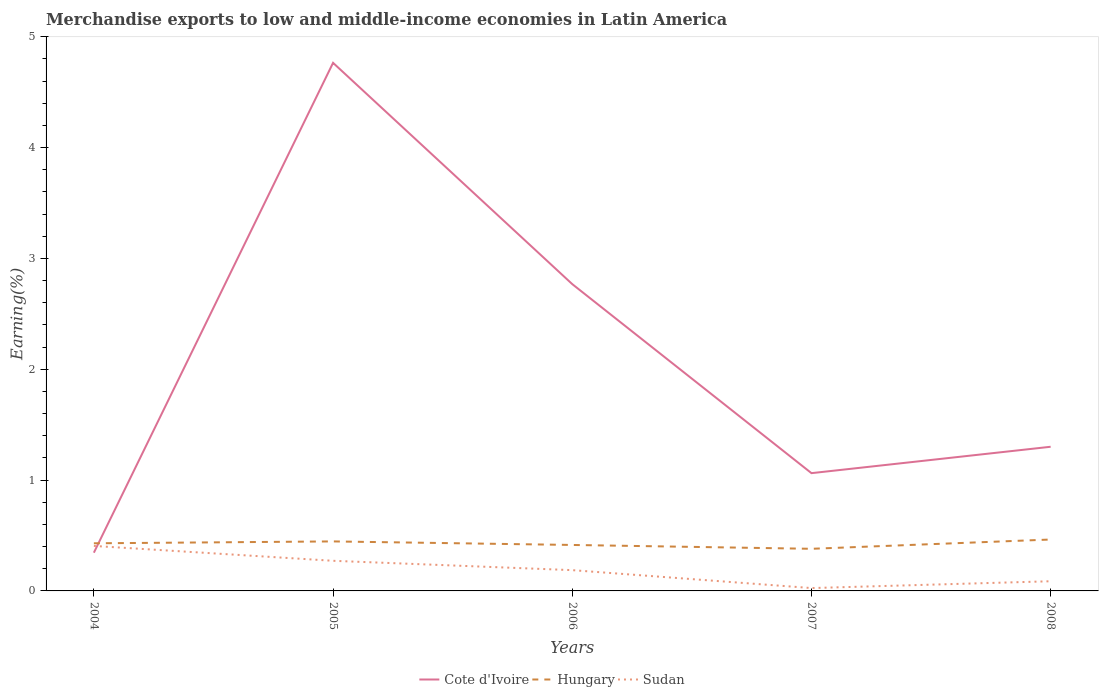How many different coloured lines are there?
Provide a short and direct response. 3. Is the number of lines equal to the number of legend labels?
Give a very brief answer. Yes. Across all years, what is the maximum percentage of amount earned from merchandise exports in Hungary?
Your response must be concise. 0.38. What is the total percentage of amount earned from merchandise exports in Cote d'Ivoire in the graph?
Keep it short and to the point. -2.42. What is the difference between the highest and the second highest percentage of amount earned from merchandise exports in Cote d'Ivoire?
Provide a succinct answer. 4.42. Is the percentage of amount earned from merchandise exports in Cote d'Ivoire strictly greater than the percentage of amount earned from merchandise exports in Sudan over the years?
Your answer should be compact. No. How many lines are there?
Offer a very short reply. 3. How many years are there in the graph?
Offer a very short reply. 5. What is the difference between two consecutive major ticks on the Y-axis?
Your answer should be very brief. 1. Does the graph contain any zero values?
Keep it short and to the point. No. Where does the legend appear in the graph?
Give a very brief answer. Bottom center. How are the legend labels stacked?
Make the answer very short. Horizontal. What is the title of the graph?
Provide a short and direct response. Merchandise exports to low and middle-income economies in Latin America. What is the label or title of the Y-axis?
Provide a succinct answer. Earning(%). What is the Earning(%) of Cote d'Ivoire in 2004?
Your response must be concise. 0.34. What is the Earning(%) of Hungary in 2004?
Your response must be concise. 0.43. What is the Earning(%) in Sudan in 2004?
Your response must be concise. 0.41. What is the Earning(%) of Cote d'Ivoire in 2005?
Keep it short and to the point. 4.76. What is the Earning(%) of Hungary in 2005?
Ensure brevity in your answer.  0.45. What is the Earning(%) in Sudan in 2005?
Offer a terse response. 0.27. What is the Earning(%) of Cote d'Ivoire in 2006?
Your answer should be compact. 2.77. What is the Earning(%) in Hungary in 2006?
Make the answer very short. 0.41. What is the Earning(%) in Sudan in 2006?
Offer a very short reply. 0.19. What is the Earning(%) of Cote d'Ivoire in 2007?
Your response must be concise. 1.06. What is the Earning(%) in Hungary in 2007?
Give a very brief answer. 0.38. What is the Earning(%) in Sudan in 2007?
Your response must be concise. 0.03. What is the Earning(%) of Cote d'Ivoire in 2008?
Give a very brief answer. 1.3. What is the Earning(%) of Hungary in 2008?
Make the answer very short. 0.46. What is the Earning(%) in Sudan in 2008?
Your answer should be compact. 0.09. Across all years, what is the maximum Earning(%) of Cote d'Ivoire?
Give a very brief answer. 4.76. Across all years, what is the maximum Earning(%) of Hungary?
Your answer should be very brief. 0.46. Across all years, what is the maximum Earning(%) in Sudan?
Provide a succinct answer. 0.41. Across all years, what is the minimum Earning(%) of Cote d'Ivoire?
Your answer should be compact. 0.34. Across all years, what is the minimum Earning(%) in Hungary?
Your answer should be very brief. 0.38. Across all years, what is the minimum Earning(%) in Sudan?
Your response must be concise. 0.03. What is the total Earning(%) in Cote d'Ivoire in the graph?
Provide a short and direct response. 10.24. What is the total Earning(%) of Hungary in the graph?
Provide a succinct answer. 2.13. What is the total Earning(%) of Sudan in the graph?
Ensure brevity in your answer.  0.98. What is the difference between the Earning(%) in Cote d'Ivoire in 2004 and that in 2005?
Offer a terse response. -4.42. What is the difference between the Earning(%) of Hungary in 2004 and that in 2005?
Make the answer very short. -0.02. What is the difference between the Earning(%) in Sudan in 2004 and that in 2005?
Provide a short and direct response. 0.13. What is the difference between the Earning(%) of Cote d'Ivoire in 2004 and that in 2006?
Make the answer very short. -2.42. What is the difference between the Earning(%) in Hungary in 2004 and that in 2006?
Ensure brevity in your answer.  0.01. What is the difference between the Earning(%) in Sudan in 2004 and that in 2006?
Make the answer very short. 0.22. What is the difference between the Earning(%) of Cote d'Ivoire in 2004 and that in 2007?
Your answer should be compact. -0.72. What is the difference between the Earning(%) of Hungary in 2004 and that in 2007?
Make the answer very short. 0.05. What is the difference between the Earning(%) in Sudan in 2004 and that in 2007?
Ensure brevity in your answer.  0.38. What is the difference between the Earning(%) in Cote d'Ivoire in 2004 and that in 2008?
Provide a short and direct response. -0.96. What is the difference between the Earning(%) of Hungary in 2004 and that in 2008?
Offer a terse response. -0.03. What is the difference between the Earning(%) in Sudan in 2004 and that in 2008?
Your answer should be compact. 0.32. What is the difference between the Earning(%) of Cote d'Ivoire in 2005 and that in 2006?
Your answer should be very brief. 2. What is the difference between the Earning(%) in Hungary in 2005 and that in 2006?
Your answer should be very brief. 0.03. What is the difference between the Earning(%) in Sudan in 2005 and that in 2006?
Your response must be concise. 0.08. What is the difference between the Earning(%) in Cote d'Ivoire in 2005 and that in 2007?
Your response must be concise. 3.7. What is the difference between the Earning(%) in Hungary in 2005 and that in 2007?
Your answer should be compact. 0.07. What is the difference between the Earning(%) of Sudan in 2005 and that in 2007?
Ensure brevity in your answer.  0.25. What is the difference between the Earning(%) in Cote d'Ivoire in 2005 and that in 2008?
Your answer should be compact. 3.46. What is the difference between the Earning(%) of Hungary in 2005 and that in 2008?
Your response must be concise. -0.02. What is the difference between the Earning(%) of Sudan in 2005 and that in 2008?
Make the answer very short. 0.18. What is the difference between the Earning(%) in Cote d'Ivoire in 2006 and that in 2007?
Provide a short and direct response. 1.71. What is the difference between the Earning(%) of Hungary in 2006 and that in 2007?
Give a very brief answer. 0.03. What is the difference between the Earning(%) of Sudan in 2006 and that in 2007?
Your answer should be compact. 0.16. What is the difference between the Earning(%) of Cote d'Ivoire in 2006 and that in 2008?
Keep it short and to the point. 1.47. What is the difference between the Earning(%) in Hungary in 2006 and that in 2008?
Ensure brevity in your answer.  -0.05. What is the difference between the Earning(%) of Sudan in 2006 and that in 2008?
Give a very brief answer. 0.1. What is the difference between the Earning(%) of Cote d'Ivoire in 2007 and that in 2008?
Provide a short and direct response. -0.24. What is the difference between the Earning(%) of Hungary in 2007 and that in 2008?
Your response must be concise. -0.08. What is the difference between the Earning(%) of Sudan in 2007 and that in 2008?
Give a very brief answer. -0.06. What is the difference between the Earning(%) in Cote d'Ivoire in 2004 and the Earning(%) in Hungary in 2005?
Keep it short and to the point. -0.1. What is the difference between the Earning(%) in Cote d'Ivoire in 2004 and the Earning(%) in Sudan in 2005?
Provide a succinct answer. 0.07. What is the difference between the Earning(%) in Hungary in 2004 and the Earning(%) in Sudan in 2005?
Ensure brevity in your answer.  0.16. What is the difference between the Earning(%) of Cote d'Ivoire in 2004 and the Earning(%) of Hungary in 2006?
Give a very brief answer. -0.07. What is the difference between the Earning(%) in Cote d'Ivoire in 2004 and the Earning(%) in Sudan in 2006?
Your answer should be very brief. 0.16. What is the difference between the Earning(%) of Hungary in 2004 and the Earning(%) of Sudan in 2006?
Ensure brevity in your answer.  0.24. What is the difference between the Earning(%) in Cote d'Ivoire in 2004 and the Earning(%) in Hungary in 2007?
Your answer should be compact. -0.04. What is the difference between the Earning(%) in Cote d'Ivoire in 2004 and the Earning(%) in Sudan in 2007?
Ensure brevity in your answer.  0.32. What is the difference between the Earning(%) in Hungary in 2004 and the Earning(%) in Sudan in 2007?
Offer a very short reply. 0.4. What is the difference between the Earning(%) in Cote d'Ivoire in 2004 and the Earning(%) in Hungary in 2008?
Keep it short and to the point. -0.12. What is the difference between the Earning(%) in Cote d'Ivoire in 2004 and the Earning(%) in Sudan in 2008?
Provide a short and direct response. 0.26. What is the difference between the Earning(%) in Hungary in 2004 and the Earning(%) in Sudan in 2008?
Ensure brevity in your answer.  0.34. What is the difference between the Earning(%) in Cote d'Ivoire in 2005 and the Earning(%) in Hungary in 2006?
Keep it short and to the point. 4.35. What is the difference between the Earning(%) of Cote d'Ivoire in 2005 and the Earning(%) of Sudan in 2006?
Keep it short and to the point. 4.58. What is the difference between the Earning(%) of Hungary in 2005 and the Earning(%) of Sudan in 2006?
Your answer should be very brief. 0.26. What is the difference between the Earning(%) in Cote d'Ivoire in 2005 and the Earning(%) in Hungary in 2007?
Give a very brief answer. 4.38. What is the difference between the Earning(%) of Cote d'Ivoire in 2005 and the Earning(%) of Sudan in 2007?
Provide a succinct answer. 4.74. What is the difference between the Earning(%) of Hungary in 2005 and the Earning(%) of Sudan in 2007?
Offer a terse response. 0.42. What is the difference between the Earning(%) in Cote d'Ivoire in 2005 and the Earning(%) in Hungary in 2008?
Offer a terse response. 4.3. What is the difference between the Earning(%) of Cote d'Ivoire in 2005 and the Earning(%) of Sudan in 2008?
Offer a very short reply. 4.68. What is the difference between the Earning(%) in Hungary in 2005 and the Earning(%) in Sudan in 2008?
Make the answer very short. 0.36. What is the difference between the Earning(%) of Cote d'Ivoire in 2006 and the Earning(%) of Hungary in 2007?
Make the answer very short. 2.39. What is the difference between the Earning(%) in Cote d'Ivoire in 2006 and the Earning(%) in Sudan in 2007?
Offer a very short reply. 2.74. What is the difference between the Earning(%) of Hungary in 2006 and the Earning(%) of Sudan in 2007?
Ensure brevity in your answer.  0.39. What is the difference between the Earning(%) of Cote d'Ivoire in 2006 and the Earning(%) of Hungary in 2008?
Give a very brief answer. 2.3. What is the difference between the Earning(%) of Cote d'Ivoire in 2006 and the Earning(%) of Sudan in 2008?
Your answer should be compact. 2.68. What is the difference between the Earning(%) of Hungary in 2006 and the Earning(%) of Sudan in 2008?
Offer a very short reply. 0.33. What is the difference between the Earning(%) in Cote d'Ivoire in 2007 and the Earning(%) in Hungary in 2008?
Your answer should be very brief. 0.6. What is the difference between the Earning(%) of Cote d'Ivoire in 2007 and the Earning(%) of Sudan in 2008?
Your answer should be compact. 0.98. What is the difference between the Earning(%) of Hungary in 2007 and the Earning(%) of Sudan in 2008?
Provide a succinct answer. 0.29. What is the average Earning(%) in Cote d'Ivoire per year?
Offer a very short reply. 2.05. What is the average Earning(%) of Hungary per year?
Offer a terse response. 0.43. What is the average Earning(%) in Sudan per year?
Your response must be concise. 0.2. In the year 2004, what is the difference between the Earning(%) of Cote d'Ivoire and Earning(%) of Hungary?
Your answer should be compact. -0.08. In the year 2004, what is the difference between the Earning(%) of Cote d'Ivoire and Earning(%) of Sudan?
Ensure brevity in your answer.  -0.06. In the year 2004, what is the difference between the Earning(%) in Hungary and Earning(%) in Sudan?
Ensure brevity in your answer.  0.02. In the year 2005, what is the difference between the Earning(%) of Cote d'Ivoire and Earning(%) of Hungary?
Make the answer very short. 4.32. In the year 2005, what is the difference between the Earning(%) in Cote d'Ivoire and Earning(%) in Sudan?
Keep it short and to the point. 4.49. In the year 2005, what is the difference between the Earning(%) of Hungary and Earning(%) of Sudan?
Offer a very short reply. 0.17. In the year 2006, what is the difference between the Earning(%) of Cote d'Ivoire and Earning(%) of Hungary?
Your response must be concise. 2.35. In the year 2006, what is the difference between the Earning(%) in Cote d'Ivoire and Earning(%) in Sudan?
Offer a very short reply. 2.58. In the year 2006, what is the difference between the Earning(%) in Hungary and Earning(%) in Sudan?
Keep it short and to the point. 0.23. In the year 2007, what is the difference between the Earning(%) in Cote d'Ivoire and Earning(%) in Hungary?
Your response must be concise. 0.68. In the year 2007, what is the difference between the Earning(%) of Cote d'Ivoire and Earning(%) of Sudan?
Keep it short and to the point. 1.04. In the year 2007, what is the difference between the Earning(%) in Hungary and Earning(%) in Sudan?
Offer a very short reply. 0.35. In the year 2008, what is the difference between the Earning(%) in Cote d'Ivoire and Earning(%) in Hungary?
Make the answer very short. 0.84. In the year 2008, what is the difference between the Earning(%) in Cote d'Ivoire and Earning(%) in Sudan?
Provide a short and direct response. 1.21. In the year 2008, what is the difference between the Earning(%) in Hungary and Earning(%) in Sudan?
Provide a short and direct response. 0.38. What is the ratio of the Earning(%) in Cote d'Ivoire in 2004 to that in 2005?
Keep it short and to the point. 0.07. What is the ratio of the Earning(%) in Hungary in 2004 to that in 2005?
Offer a very short reply. 0.96. What is the ratio of the Earning(%) of Sudan in 2004 to that in 2005?
Your answer should be very brief. 1.49. What is the ratio of the Earning(%) in Cote d'Ivoire in 2004 to that in 2006?
Offer a terse response. 0.12. What is the ratio of the Earning(%) of Hungary in 2004 to that in 2006?
Your answer should be very brief. 1.04. What is the ratio of the Earning(%) of Sudan in 2004 to that in 2006?
Ensure brevity in your answer.  2.17. What is the ratio of the Earning(%) of Cote d'Ivoire in 2004 to that in 2007?
Provide a succinct answer. 0.32. What is the ratio of the Earning(%) in Hungary in 2004 to that in 2007?
Your answer should be very brief. 1.13. What is the ratio of the Earning(%) of Sudan in 2004 to that in 2007?
Offer a very short reply. 15.79. What is the ratio of the Earning(%) of Cote d'Ivoire in 2004 to that in 2008?
Give a very brief answer. 0.27. What is the ratio of the Earning(%) in Hungary in 2004 to that in 2008?
Your answer should be compact. 0.93. What is the ratio of the Earning(%) of Sudan in 2004 to that in 2008?
Keep it short and to the point. 4.65. What is the ratio of the Earning(%) in Cote d'Ivoire in 2005 to that in 2006?
Ensure brevity in your answer.  1.72. What is the ratio of the Earning(%) in Hungary in 2005 to that in 2006?
Your response must be concise. 1.08. What is the ratio of the Earning(%) in Sudan in 2005 to that in 2006?
Ensure brevity in your answer.  1.45. What is the ratio of the Earning(%) of Cote d'Ivoire in 2005 to that in 2007?
Offer a terse response. 4.48. What is the ratio of the Earning(%) of Hungary in 2005 to that in 2007?
Provide a succinct answer. 1.18. What is the ratio of the Earning(%) of Sudan in 2005 to that in 2007?
Provide a short and direct response. 10.57. What is the ratio of the Earning(%) of Cote d'Ivoire in 2005 to that in 2008?
Give a very brief answer. 3.66. What is the ratio of the Earning(%) in Hungary in 2005 to that in 2008?
Provide a succinct answer. 0.96. What is the ratio of the Earning(%) of Sudan in 2005 to that in 2008?
Offer a terse response. 3.11. What is the ratio of the Earning(%) of Cote d'Ivoire in 2006 to that in 2007?
Provide a succinct answer. 2.6. What is the ratio of the Earning(%) of Hungary in 2006 to that in 2007?
Provide a short and direct response. 1.09. What is the ratio of the Earning(%) of Sudan in 2006 to that in 2007?
Ensure brevity in your answer.  7.29. What is the ratio of the Earning(%) of Cote d'Ivoire in 2006 to that in 2008?
Provide a short and direct response. 2.13. What is the ratio of the Earning(%) of Hungary in 2006 to that in 2008?
Offer a very short reply. 0.89. What is the ratio of the Earning(%) of Sudan in 2006 to that in 2008?
Provide a succinct answer. 2.15. What is the ratio of the Earning(%) in Cote d'Ivoire in 2007 to that in 2008?
Your response must be concise. 0.82. What is the ratio of the Earning(%) in Hungary in 2007 to that in 2008?
Keep it short and to the point. 0.82. What is the ratio of the Earning(%) in Sudan in 2007 to that in 2008?
Offer a terse response. 0.29. What is the difference between the highest and the second highest Earning(%) in Cote d'Ivoire?
Offer a terse response. 2. What is the difference between the highest and the second highest Earning(%) of Hungary?
Your answer should be compact. 0.02. What is the difference between the highest and the second highest Earning(%) in Sudan?
Provide a succinct answer. 0.13. What is the difference between the highest and the lowest Earning(%) of Cote d'Ivoire?
Offer a very short reply. 4.42. What is the difference between the highest and the lowest Earning(%) in Hungary?
Offer a terse response. 0.08. What is the difference between the highest and the lowest Earning(%) in Sudan?
Give a very brief answer. 0.38. 